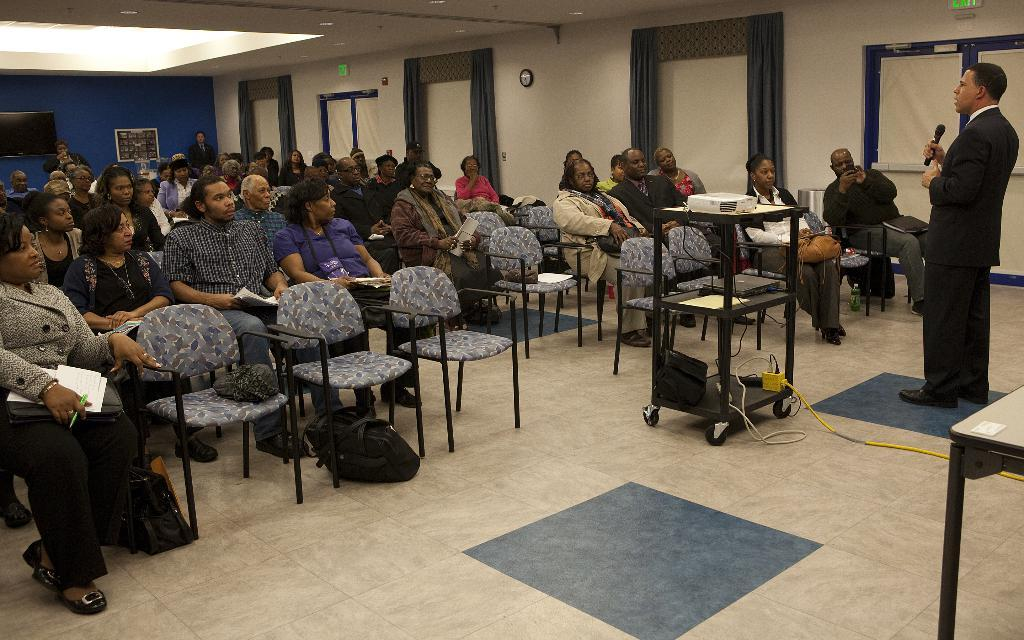How many people are in the image? There is a group of people in the image. What are the people doing in the image? The people are sitting on chairs. What can be seen in the background of the image? There is a curtain and a wall in the background of the image. What store are the people in the image shopping at? There is no reference to a store in the image. 